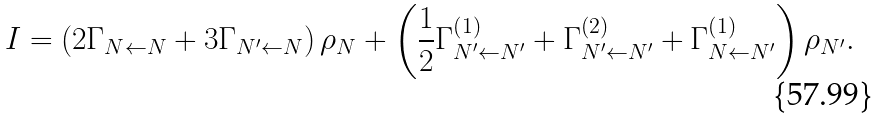<formula> <loc_0><loc_0><loc_500><loc_500>I = \left ( 2 \Gamma _ { N \leftarrow N } + 3 \Gamma _ { N ^ { \prime } \leftarrow N } \right ) \rho _ { N } + \left ( \frac { 1 } { 2 } \Gamma _ { N ^ { \prime } \leftarrow N ^ { \prime } } ^ { \left ( 1 \right ) } + \Gamma _ { N ^ { \prime } \leftarrow N ^ { \prime } } ^ { \left ( 2 \right ) } + \Gamma _ { N \leftarrow N ^ { \prime } } ^ { \left ( 1 \right ) } \right ) \rho _ { N ^ { \prime } } .</formula> 